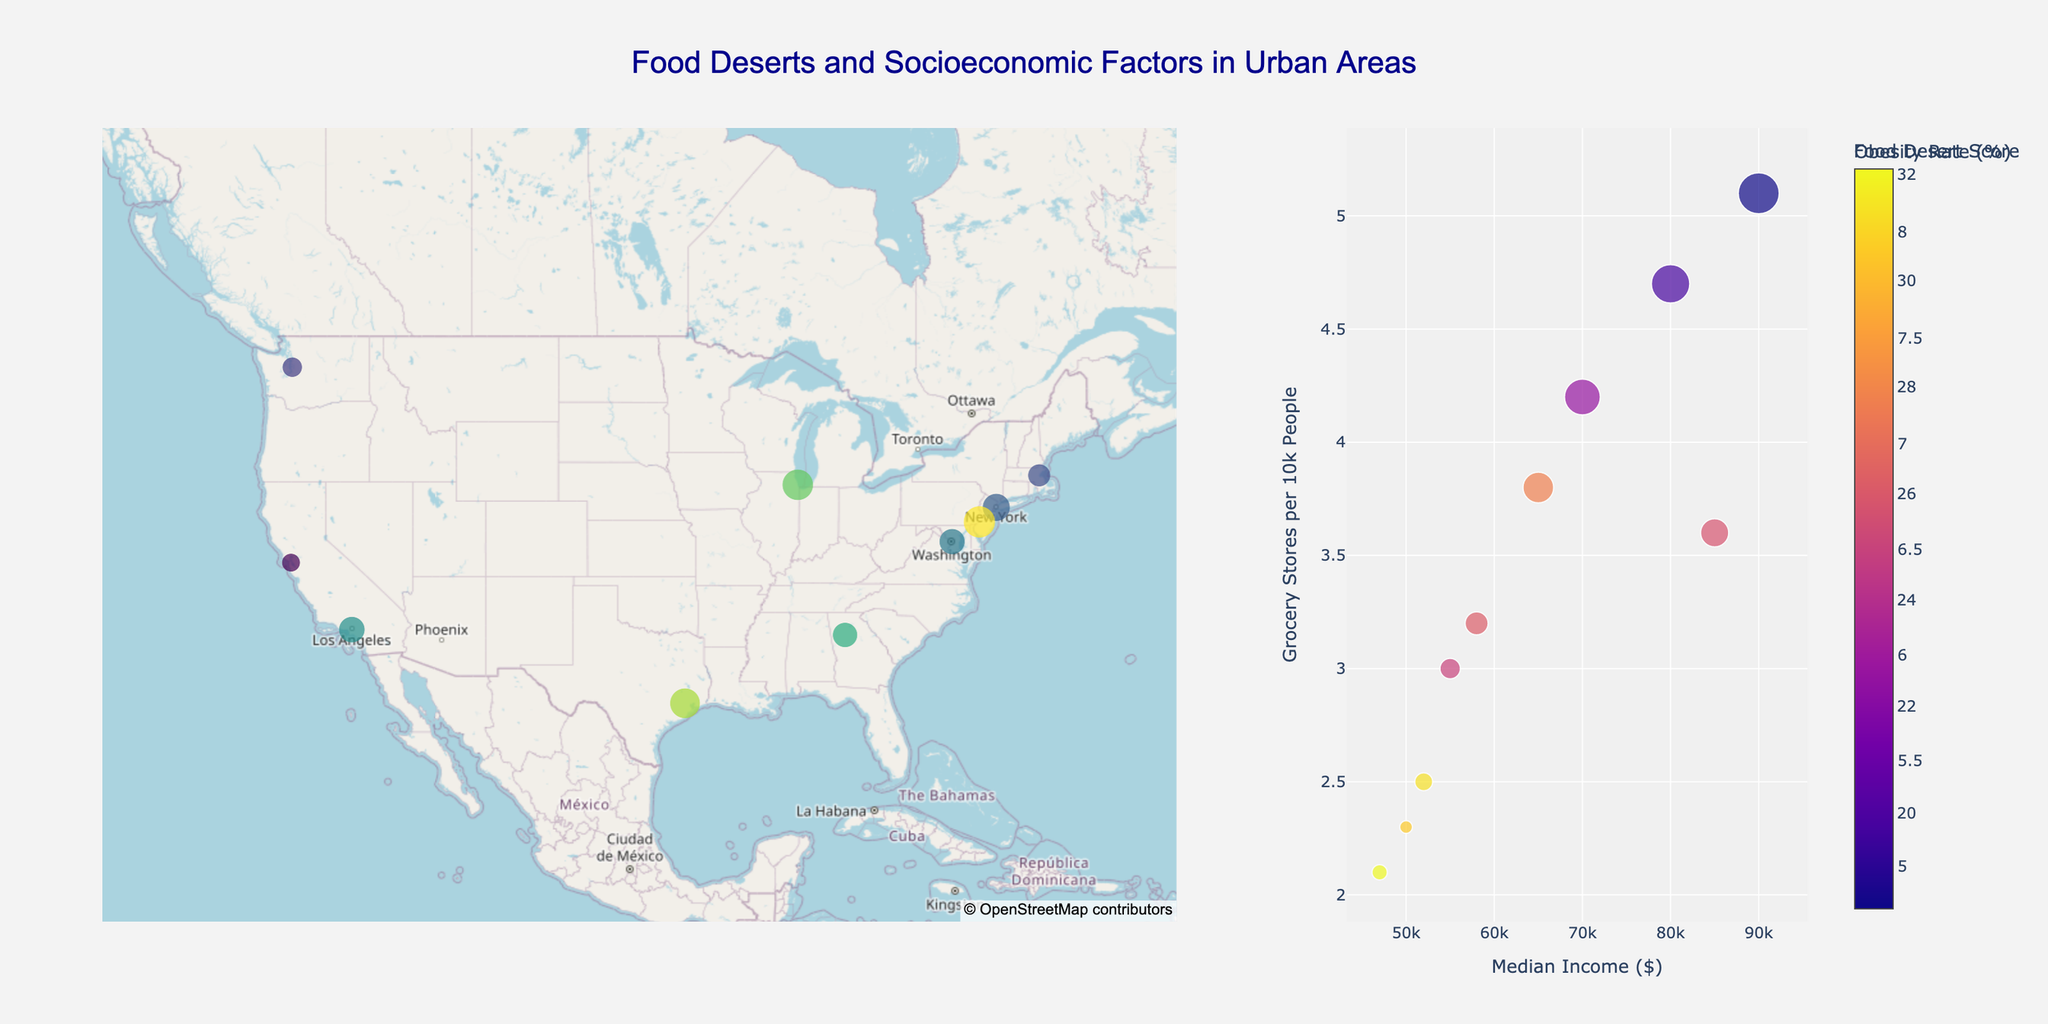What's the title of the figure? The title is written at the top center of the figure. It serves as a summary of what the figure represents, providing context to the viewer.
Answer: Food Deserts and Socioeconomic Factors in Urban Areas Which city has the highest Food Desert Score? By looking at the scatter plot and the geographical plot, the highest Food Desert Score is represented by the size of the markers. Philadelphia has the highest Food Desert Score visible in the map section of the figure.
Answer: Philadelphia How does the color scale in the map plot represent obesity rates? In the map plot, the color scale that ranges from light to dark colors is used to represent the obesity rates. Cities with higher obesity rates are marked with darker colors.
Answer: Higher obesity rates are in darker colors Between San Francisco and Chicago, which city has more grocery stores per 10k people? By referring to the scatter plot on the right, San Francisco and Chicago can be compared by finding their corresponding data points and noting their positions on the y-axis. San Francisco's dot is higher on the y-axis, indicating more grocery stores per 10k people.
Answer: San Francisco Which city has the highest median income and how is it represented? On the scatter plot, the city with the highest median income will be the farthest to the right on the x-axis. San Francisco is positioned the furthest to the right, indicating the highest median income.
Answer: San Francisco What correlation can be seen between the number of health education programs and Food Desert Scores? In the scatter plot, larger markers represent more health education programs. Observing the size of the markers and their color coding, cities with more health education programs tend to have lower Food Desert Scores.
Answer: More health education programs correlate with lower Food Desert Scores How many cities in the dataset have a Food Desert Score above 7? By examining the geographical map and referring to the size of the markers, and then cross-checking with the scatter plot, you can count the cities. New York City, Chicago, Houston, and Philadelphia all have a Food Desert Score above 7.
Answer: Four cities Compare the obesity rate difference between Seattle and Boston. On the geographical map, the colors of the markers indicate obesity rates. Seattle's marker is slightly lighter than Boston's, which suggests that Seattle has a lower obesity rate.
Answer: Boston has a higher obesity rate than Seattle What does a larger marker in the scatter plot indicate? Larger markers in the scatter plot indicate a greater number of health education programs. Each marker size is scaled according to the number of health education programs in the corresponding city.
Answer: More health education programs If a city has more grocery stores per 10k people, what can you infer about its Food Desert Score? Observing the scatter plot, cities with more grocery stores per 10k people tend to be found lower down on the color scale used for Food Desert Scores. This suggests that a higher number of grocery stores per 10k people generally correlates with a lower Food Desert Score.
Answer: More grocery stores per 10k generally imply a lower Food Desert Score 